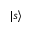<formula> <loc_0><loc_0><loc_500><loc_500>| s \rangle</formula> 